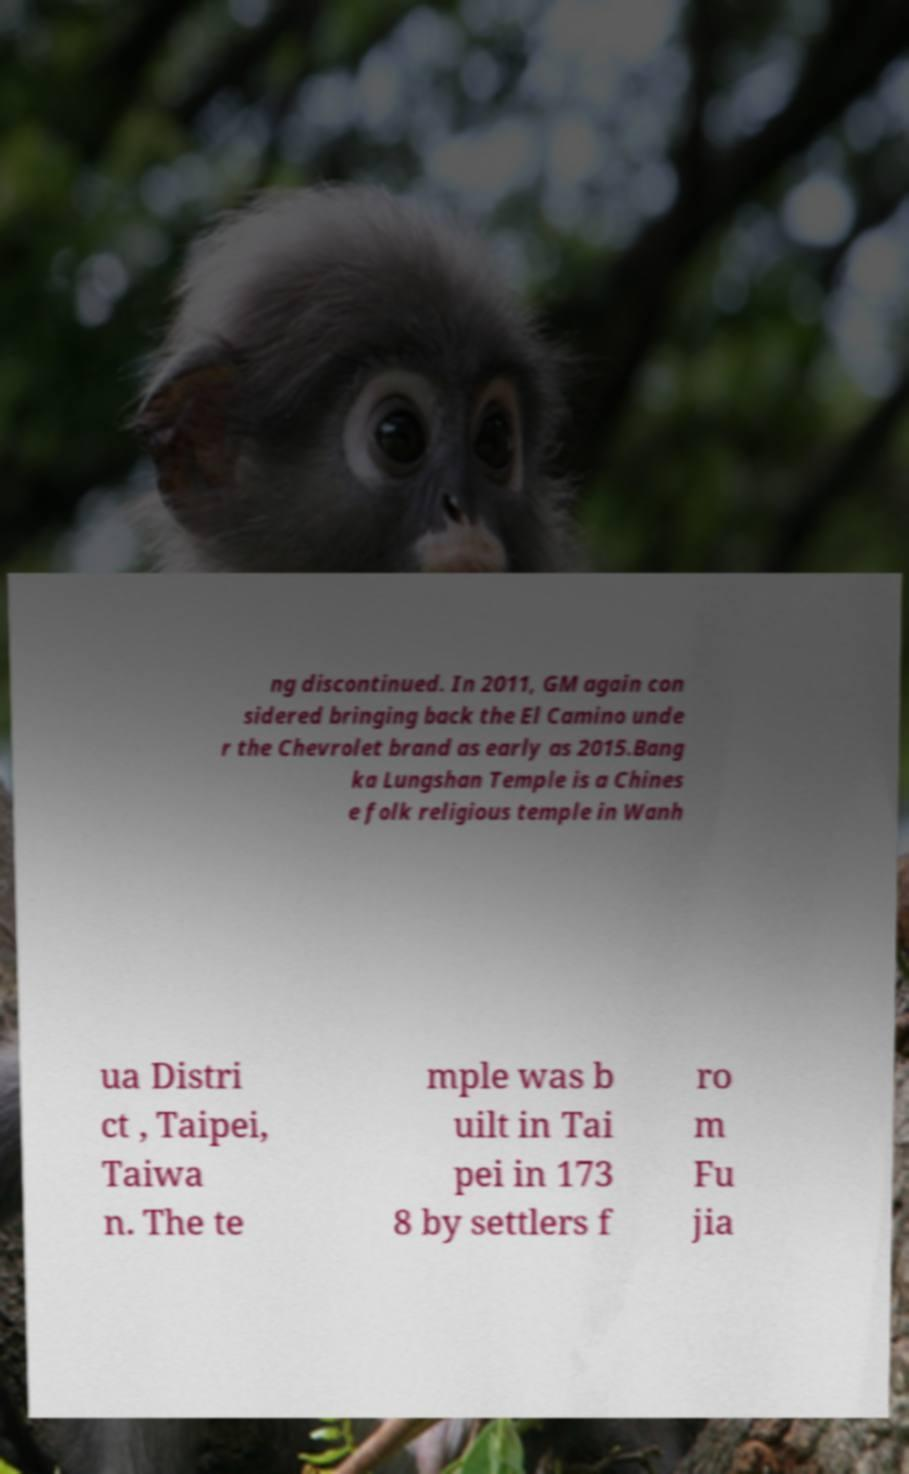There's text embedded in this image that I need extracted. Can you transcribe it verbatim? ng discontinued. In 2011, GM again con sidered bringing back the El Camino unde r the Chevrolet brand as early as 2015.Bang ka Lungshan Temple is a Chines e folk religious temple in Wanh ua Distri ct , Taipei, Taiwa n. The te mple was b uilt in Tai pei in 173 8 by settlers f ro m Fu jia 